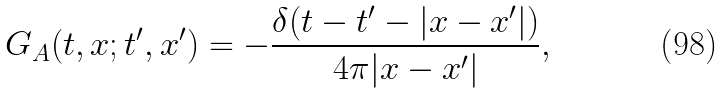Convert formula to latex. <formula><loc_0><loc_0><loc_500><loc_500>G _ { A } ( t , { x } ; t ^ { \prime } , { x } ^ { \prime } ) = - \frac { \delta ( t - t ^ { \prime } - | { x } - { x } ^ { \prime } | ) } { 4 \pi | { x } - { x } ^ { \prime } | } ,</formula> 